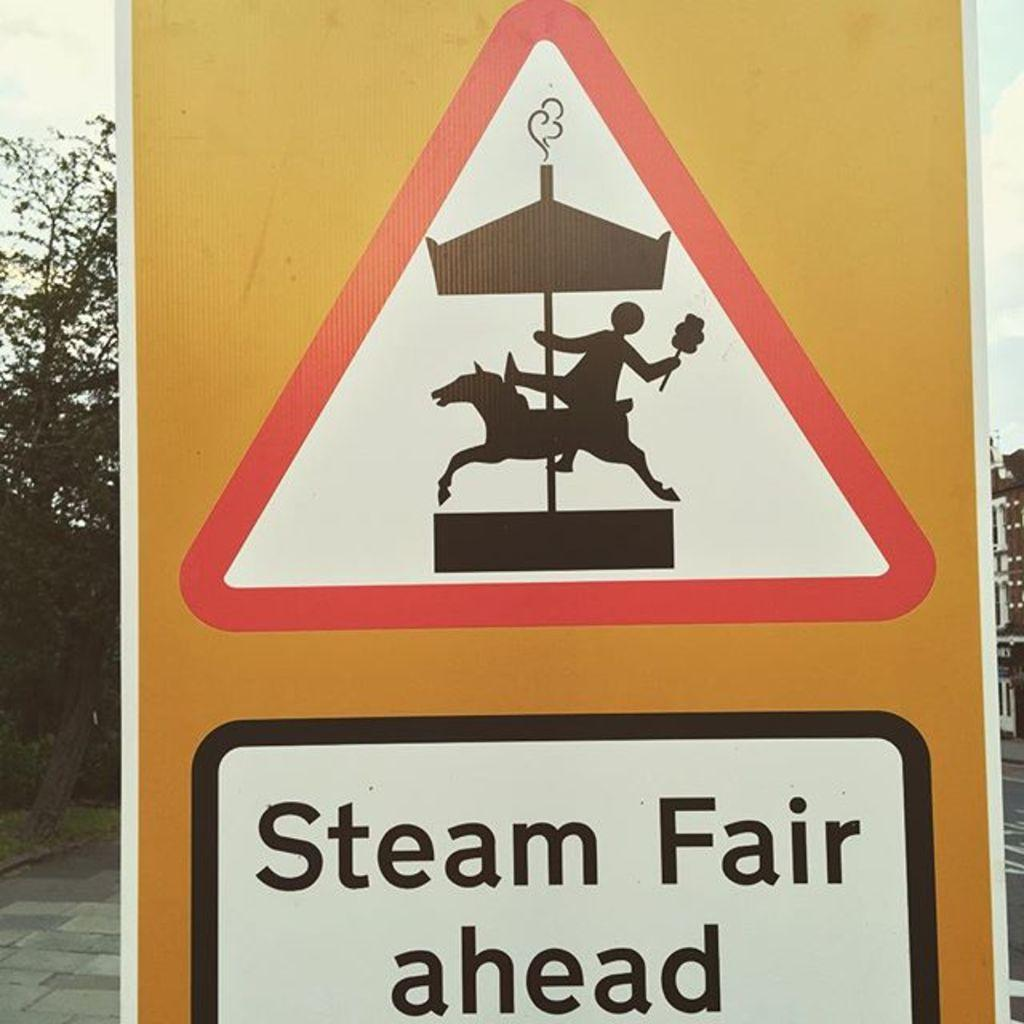<image>
Write a terse but informative summary of the picture. A sign depicting a merry go road has the words "Steam Fair ahead" on it. 